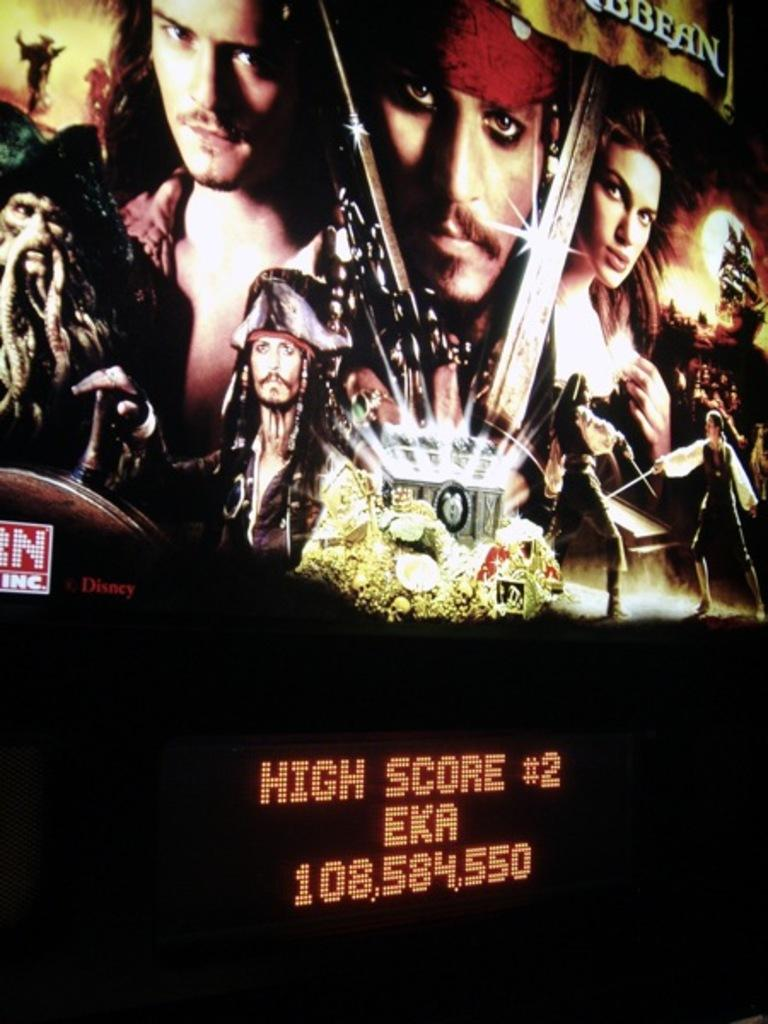<image>
Present a compact description of the photo's key features. A video screen with Pirates of the Caribbean at the top and "High Score # 2" at the bottom of the screen. 